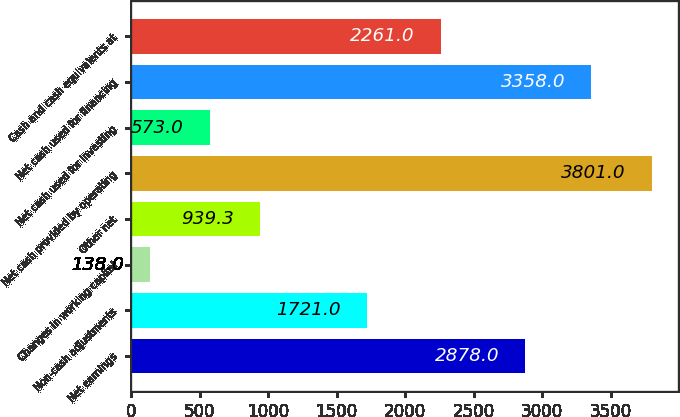Convert chart to OTSL. <chart><loc_0><loc_0><loc_500><loc_500><bar_chart><fcel>Net earnings<fcel>Non-cash adjustments<fcel>Changes in working capital<fcel>Other net<fcel>Net cash provided by operating<fcel>Net cash used for investing<fcel>Net cash used for financing<fcel>Cash and cash equivalents at<nl><fcel>2878<fcel>1721<fcel>138<fcel>939.3<fcel>3801<fcel>573<fcel>3358<fcel>2261<nl></chart> 